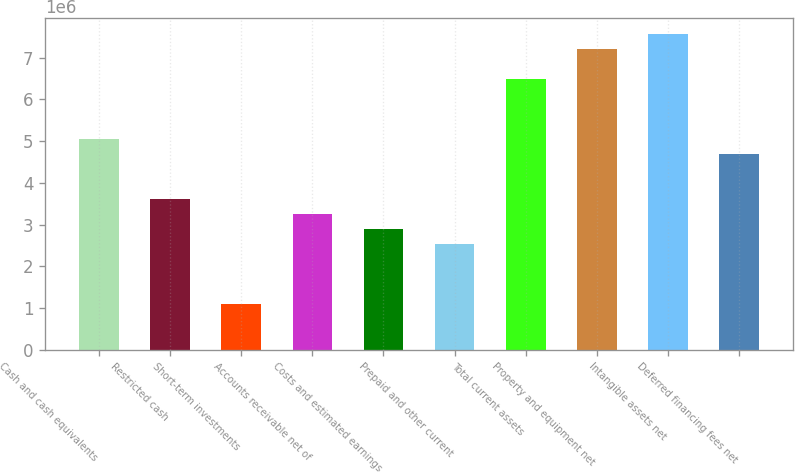<chart> <loc_0><loc_0><loc_500><loc_500><bar_chart><fcel>Cash and cash equivalents<fcel>Restricted cash<fcel>Short-term investments<fcel>Accounts receivable net of<fcel>Costs and estimated earnings<fcel>Prepaid and other current<fcel>Total current assets<fcel>Property and equipment net<fcel>Intangible assets net<fcel>Deferred financing fees net<nl><fcel>5.04876e+06<fcel>3.6064e+06<fcel>1.08226e+06<fcel>3.24581e+06<fcel>2.88522e+06<fcel>2.52462e+06<fcel>6.49113e+06<fcel>7.21231e+06<fcel>7.5729e+06<fcel>4.68817e+06<nl></chart> 